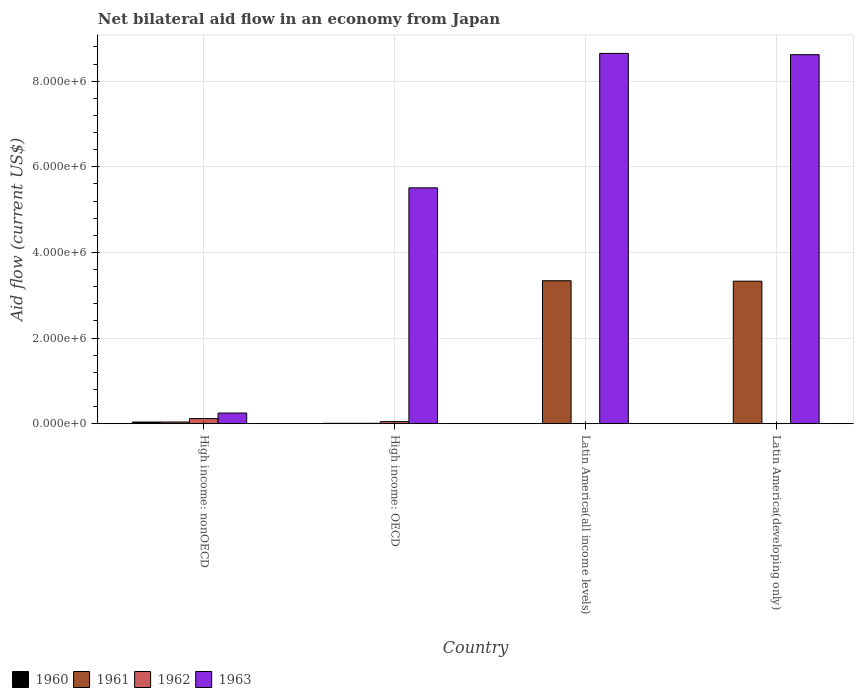How many different coloured bars are there?
Your response must be concise. 4. Are the number of bars on each tick of the X-axis equal?
Your answer should be compact. No. How many bars are there on the 2nd tick from the left?
Your answer should be very brief. 4. How many bars are there on the 2nd tick from the right?
Offer a very short reply. 2. What is the label of the 2nd group of bars from the left?
Keep it short and to the point. High income: OECD. What is the net bilateral aid flow in 1960 in High income: nonOECD?
Your response must be concise. 4.00e+04. Across all countries, what is the maximum net bilateral aid flow in 1961?
Offer a very short reply. 3.34e+06. In which country was the net bilateral aid flow in 1963 maximum?
Make the answer very short. Latin America(all income levels). What is the total net bilateral aid flow in 1963 in the graph?
Provide a short and direct response. 2.30e+07. What is the difference between the net bilateral aid flow in 1960 in Latin America(all income levels) and the net bilateral aid flow in 1961 in Latin America(developing only)?
Offer a very short reply. -3.33e+06. What is the average net bilateral aid flow in 1961 per country?
Make the answer very short. 1.68e+06. What is the ratio of the net bilateral aid flow in 1963 in Latin America(all income levels) to that in Latin America(developing only)?
Ensure brevity in your answer.  1. Is the difference between the net bilateral aid flow in 1960 in High income: OECD and High income: nonOECD greater than the difference between the net bilateral aid flow in 1963 in High income: OECD and High income: nonOECD?
Your answer should be very brief. No. What is the difference between the highest and the second highest net bilateral aid flow in 1963?
Offer a terse response. 3.00e+04. What is the difference between the highest and the lowest net bilateral aid flow in 1963?
Your answer should be compact. 8.40e+06. Is it the case that in every country, the sum of the net bilateral aid flow in 1961 and net bilateral aid flow in 1963 is greater than the sum of net bilateral aid flow in 1960 and net bilateral aid flow in 1962?
Provide a succinct answer. No. Is it the case that in every country, the sum of the net bilateral aid flow in 1962 and net bilateral aid flow in 1963 is greater than the net bilateral aid flow in 1961?
Provide a short and direct response. Yes. How many bars are there?
Keep it short and to the point. 12. What is the difference between two consecutive major ticks on the Y-axis?
Provide a short and direct response. 2.00e+06. Are the values on the major ticks of Y-axis written in scientific E-notation?
Your answer should be compact. Yes. Does the graph contain any zero values?
Keep it short and to the point. Yes. Does the graph contain grids?
Your response must be concise. Yes. How many legend labels are there?
Your answer should be very brief. 4. How are the legend labels stacked?
Your response must be concise. Horizontal. What is the title of the graph?
Give a very brief answer. Net bilateral aid flow in an economy from Japan. What is the label or title of the X-axis?
Your answer should be compact. Country. What is the Aid flow (current US$) in 1960 in High income: nonOECD?
Your answer should be compact. 4.00e+04. What is the Aid flow (current US$) in 1960 in High income: OECD?
Offer a very short reply. 10000. What is the Aid flow (current US$) of 1962 in High income: OECD?
Your response must be concise. 5.00e+04. What is the Aid flow (current US$) of 1963 in High income: OECD?
Give a very brief answer. 5.51e+06. What is the Aid flow (current US$) in 1961 in Latin America(all income levels)?
Your response must be concise. 3.34e+06. What is the Aid flow (current US$) of 1963 in Latin America(all income levels)?
Make the answer very short. 8.65e+06. What is the Aid flow (current US$) of 1961 in Latin America(developing only)?
Provide a short and direct response. 3.33e+06. What is the Aid flow (current US$) of 1963 in Latin America(developing only)?
Your answer should be very brief. 8.62e+06. Across all countries, what is the maximum Aid flow (current US$) in 1960?
Offer a very short reply. 4.00e+04. Across all countries, what is the maximum Aid flow (current US$) in 1961?
Provide a short and direct response. 3.34e+06. Across all countries, what is the maximum Aid flow (current US$) of 1962?
Your response must be concise. 1.20e+05. Across all countries, what is the maximum Aid flow (current US$) of 1963?
Provide a short and direct response. 8.65e+06. Across all countries, what is the minimum Aid flow (current US$) in 1961?
Ensure brevity in your answer.  10000. Across all countries, what is the minimum Aid flow (current US$) of 1963?
Your response must be concise. 2.50e+05. What is the total Aid flow (current US$) in 1961 in the graph?
Your answer should be compact. 6.72e+06. What is the total Aid flow (current US$) of 1962 in the graph?
Keep it short and to the point. 1.70e+05. What is the total Aid flow (current US$) in 1963 in the graph?
Offer a very short reply. 2.30e+07. What is the difference between the Aid flow (current US$) of 1961 in High income: nonOECD and that in High income: OECD?
Make the answer very short. 3.00e+04. What is the difference between the Aid flow (current US$) of 1963 in High income: nonOECD and that in High income: OECD?
Give a very brief answer. -5.26e+06. What is the difference between the Aid flow (current US$) of 1961 in High income: nonOECD and that in Latin America(all income levels)?
Offer a terse response. -3.30e+06. What is the difference between the Aid flow (current US$) in 1963 in High income: nonOECD and that in Latin America(all income levels)?
Offer a very short reply. -8.40e+06. What is the difference between the Aid flow (current US$) of 1961 in High income: nonOECD and that in Latin America(developing only)?
Your answer should be very brief. -3.29e+06. What is the difference between the Aid flow (current US$) of 1963 in High income: nonOECD and that in Latin America(developing only)?
Ensure brevity in your answer.  -8.37e+06. What is the difference between the Aid flow (current US$) of 1961 in High income: OECD and that in Latin America(all income levels)?
Ensure brevity in your answer.  -3.33e+06. What is the difference between the Aid flow (current US$) in 1963 in High income: OECD and that in Latin America(all income levels)?
Ensure brevity in your answer.  -3.14e+06. What is the difference between the Aid flow (current US$) of 1961 in High income: OECD and that in Latin America(developing only)?
Give a very brief answer. -3.32e+06. What is the difference between the Aid flow (current US$) of 1963 in High income: OECD and that in Latin America(developing only)?
Offer a very short reply. -3.11e+06. What is the difference between the Aid flow (current US$) of 1963 in Latin America(all income levels) and that in Latin America(developing only)?
Your answer should be compact. 3.00e+04. What is the difference between the Aid flow (current US$) of 1960 in High income: nonOECD and the Aid flow (current US$) of 1961 in High income: OECD?
Your answer should be compact. 3.00e+04. What is the difference between the Aid flow (current US$) of 1960 in High income: nonOECD and the Aid flow (current US$) of 1962 in High income: OECD?
Your response must be concise. -10000. What is the difference between the Aid flow (current US$) in 1960 in High income: nonOECD and the Aid flow (current US$) in 1963 in High income: OECD?
Provide a succinct answer. -5.47e+06. What is the difference between the Aid flow (current US$) in 1961 in High income: nonOECD and the Aid flow (current US$) in 1962 in High income: OECD?
Offer a terse response. -10000. What is the difference between the Aid flow (current US$) of 1961 in High income: nonOECD and the Aid flow (current US$) of 1963 in High income: OECD?
Provide a short and direct response. -5.47e+06. What is the difference between the Aid flow (current US$) of 1962 in High income: nonOECD and the Aid flow (current US$) of 1963 in High income: OECD?
Provide a short and direct response. -5.39e+06. What is the difference between the Aid flow (current US$) of 1960 in High income: nonOECD and the Aid flow (current US$) of 1961 in Latin America(all income levels)?
Make the answer very short. -3.30e+06. What is the difference between the Aid flow (current US$) in 1960 in High income: nonOECD and the Aid flow (current US$) in 1963 in Latin America(all income levels)?
Offer a terse response. -8.61e+06. What is the difference between the Aid flow (current US$) of 1961 in High income: nonOECD and the Aid flow (current US$) of 1963 in Latin America(all income levels)?
Offer a terse response. -8.61e+06. What is the difference between the Aid flow (current US$) in 1962 in High income: nonOECD and the Aid flow (current US$) in 1963 in Latin America(all income levels)?
Make the answer very short. -8.53e+06. What is the difference between the Aid flow (current US$) of 1960 in High income: nonOECD and the Aid flow (current US$) of 1961 in Latin America(developing only)?
Provide a short and direct response. -3.29e+06. What is the difference between the Aid flow (current US$) of 1960 in High income: nonOECD and the Aid flow (current US$) of 1963 in Latin America(developing only)?
Provide a short and direct response. -8.58e+06. What is the difference between the Aid flow (current US$) of 1961 in High income: nonOECD and the Aid flow (current US$) of 1963 in Latin America(developing only)?
Your answer should be very brief. -8.58e+06. What is the difference between the Aid flow (current US$) in 1962 in High income: nonOECD and the Aid flow (current US$) in 1963 in Latin America(developing only)?
Make the answer very short. -8.50e+06. What is the difference between the Aid flow (current US$) of 1960 in High income: OECD and the Aid flow (current US$) of 1961 in Latin America(all income levels)?
Provide a succinct answer. -3.33e+06. What is the difference between the Aid flow (current US$) in 1960 in High income: OECD and the Aid flow (current US$) in 1963 in Latin America(all income levels)?
Offer a terse response. -8.64e+06. What is the difference between the Aid flow (current US$) of 1961 in High income: OECD and the Aid flow (current US$) of 1963 in Latin America(all income levels)?
Give a very brief answer. -8.64e+06. What is the difference between the Aid flow (current US$) in 1962 in High income: OECD and the Aid flow (current US$) in 1963 in Latin America(all income levels)?
Your response must be concise. -8.60e+06. What is the difference between the Aid flow (current US$) in 1960 in High income: OECD and the Aid flow (current US$) in 1961 in Latin America(developing only)?
Your answer should be very brief. -3.32e+06. What is the difference between the Aid flow (current US$) in 1960 in High income: OECD and the Aid flow (current US$) in 1963 in Latin America(developing only)?
Offer a terse response. -8.61e+06. What is the difference between the Aid flow (current US$) of 1961 in High income: OECD and the Aid flow (current US$) of 1963 in Latin America(developing only)?
Keep it short and to the point. -8.61e+06. What is the difference between the Aid flow (current US$) of 1962 in High income: OECD and the Aid flow (current US$) of 1963 in Latin America(developing only)?
Give a very brief answer. -8.57e+06. What is the difference between the Aid flow (current US$) of 1961 in Latin America(all income levels) and the Aid flow (current US$) of 1963 in Latin America(developing only)?
Make the answer very short. -5.28e+06. What is the average Aid flow (current US$) in 1960 per country?
Ensure brevity in your answer.  1.25e+04. What is the average Aid flow (current US$) of 1961 per country?
Your answer should be compact. 1.68e+06. What is the average Aid flow (current US$) in 1962 per country?
Offer a terse response. 4.25e+04. What is the average Aid flow (current US$) of 1963 per country?
Offer a very short reply. 5.76e+06. What is the difference between the Aid flow (current US$) of 1960 and Aid flow (current US$) of 1961 in High income: nonOECD?
Offer a very short reply. 0. What is the difference between the Aid flow (current US$) in 1960 and Aid flow (current US$) in 1963 in High income: nonOECD?
Offer a very short reply. -2.10e+05. What is the difference between the Aid flow (current US$) in 1961 and Aid flow (current US$) in 1963 in High income: nonOECD?
Provide a succinct answer. -2.10e+05. What is the difference between the Aid flow (current US$) in 1962 and Aid flow (current US$) in 1963 in High income: nonOECD?
Offer a very short reply. -1.30e+05. What is the difference between the Aid flow (current US$) in 1960 and Aid flow (current US$) in 1962 in High income: OECD?
Your answer should be very brief. -4.00e+04. What is the difference between the Aid flow (current US$) of 1960 and Aid flow (current US$) of 1963 in High income: OECD?
Your answer should be very brief. -5.50e+06. What is the difference between the Aid flow (current US$) in 1961 and Aid flow (current US$) in 1962 in High income: OECD?
Your answer should be compact. -4.00e+04. What is the difference between the Aid flow (current US$) of 1961 and Aid flow (current US$) of 1963 in High income: OECD?
Your answer should be compact. -5.50e+06. What is the difference between the Aid flow (current US$) in 1962 and Aid flow (current US$) in 1963 in High income: OECD?
Ensure brevity in your answer.  -5.46e+06. What is the difference between the Aid flow (current US$) of 1961 and Aid flow (current US$) of 1963 in Latin America(all income levels)?
Offer a very short reply. -5.31e+06. What is the difference between the Aid flow (current US$) in 1961 and Aid flow (current US$) in 1963 in Latin America(developing only)?
Keep it short and to the point. -5.29e+06. What is the ratio of the Aid flow (current US$) in 1961 in High income: nonOECD to that in High income: OECD?
Your response must be concise. 4. What is the ratio of the Aid flow (current US$) of 1963 in High income: nonOECD to that in High income: OECD?
Provide a succinct answer. 0.05. What is the ratio of the Aid flow (current US$) of 1961 in High income: nonOECD to that in Latin America(all income levels)?
Your answer should be compact. 0.01. What is the ratio of the Aid flow (current US$) of 1963 in High income: nonOECD to that in Latin America(all income levels)?
Offer a very short reply. 0.03. What is the ratio of the Aid flow (current US$) in 1961 in High income: nonOECD to that in Latin America(developing only)?
Provide a short and direct response. 0.01. What is the ratio of the Aid flow (current US$) of 1963 in High income: nonOECD to that in Latin America(developing only)?
Offer a very short reply. 0.03. What is the ratio of the Aid flow (current US$) in 1961 in High income: OECD to that in Latin America(all income levels)?
Ensure brevity in your answer.  0. What is the ratio of the Aid flow (current US$) of 1963 in High income: OECD to that in Latin America(all income levels)?
Keep it short and to the point. 0.64. What is the ratio of the Aid flow (current US$) in 1961 in High income: OECD to that in Latin America(developing only)?
Give a very brief answer. 0. What is the ratio of the Aid flow (current US$) in 1963 in High income: OECD to that in Latin America(developing only)?
Your answer should be compact. 0.64. What is the ratio of the Aid flow (current US$) of 1963 in Latin America(all income levels) to that in Latin America(developing only)?
Provide a short and direct response. 1. What is the difference between the highest and the lowest Aid flow (current US$) of 1961?
Offer a terse response. 3.33e+06. What is the difference between the highest and the lowest Aid flow (current US$) in 1963?
Offer a very short reply. 8.40e+06. 